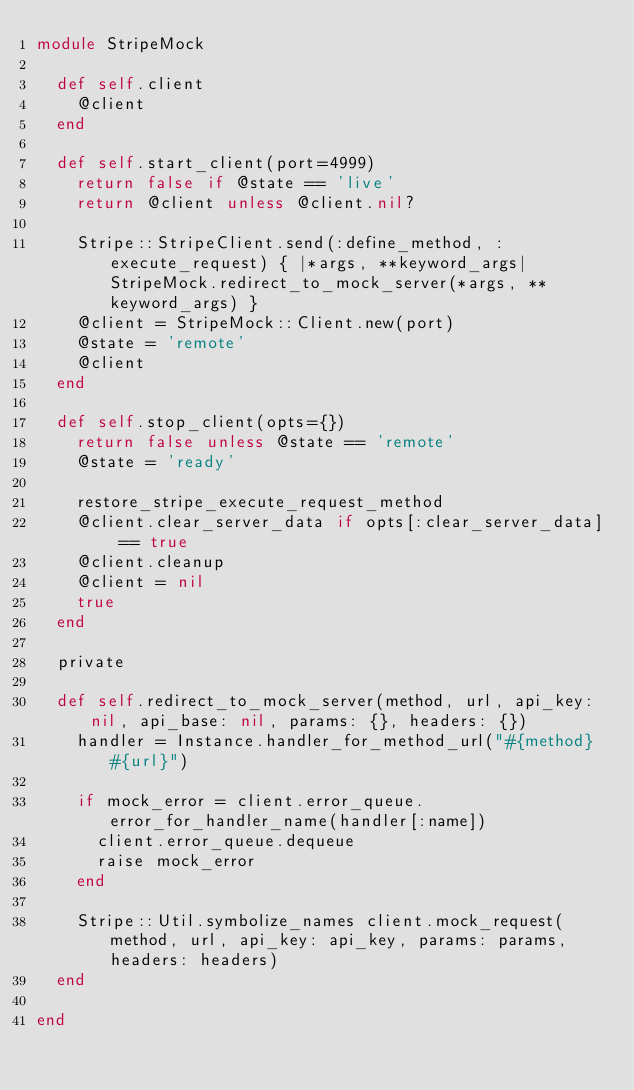Convert code to text. <code><loc_0><loc_0><loc_500><loc_500><_Ruby_>module StripeMock

  def self.client
    @client
  end

  def self.start_client(port=4999)
    return false if @state == 'live'
    return @client unless @client.nil?

    Stripe::StripeClient.send(:define_method, :execute_request) { |*args, **keyword_args| StripeMock.redirect_to_mock_server(*args, **keyword_args) }
    @client = StripeMock::Client.new(port)
    @state = 'remote'
    @client
  end

  def self.stop_client(opts={})
    return false unless @state == 'remote'
    @state = 'ready'

    restore_stripe_execute_request_method
    @client.clear_server_data if opts[:clear_server_data] == true
    @client.cleanup
    @client = nil
    true
  end

  private

  def self.redirect_to_mock_server(method, url, api_key: nil, api_base: nil, params: {}, headers: {})
    handler = Instance.handler_for_method_url("#{method} #{url}")

    if mock_error = client.error_queue.error_for_handler_name(handler[:name])
      client.error_queue.dequeue
      raise mock_error
    end

    Stripe::Util.symbolize_names client.mock_request(method, url, api_key: api_key, params: params, headers: headers)
  end

end
</code> 